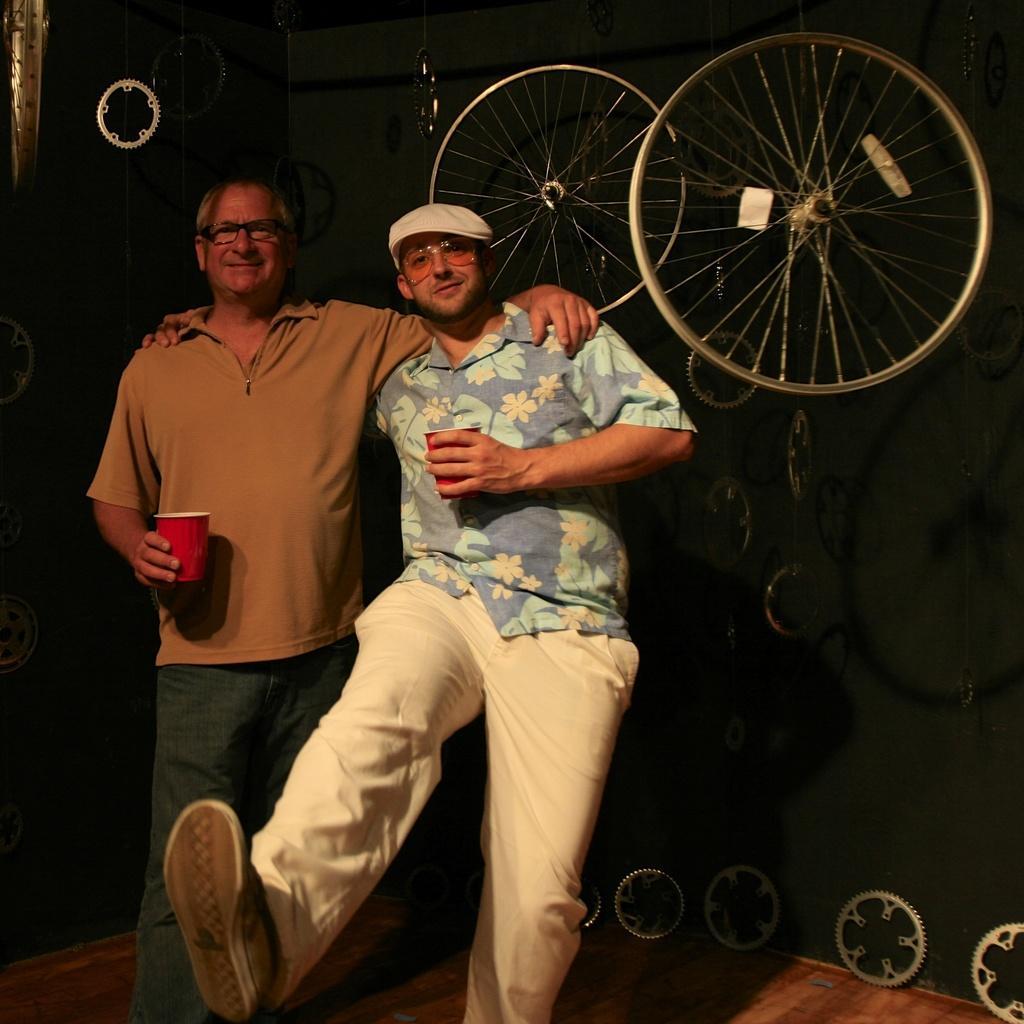Please provide a concise description of this image. In this image we can see two member standing holding a glass. In the background of the image there are tires and gears. At the bottom of the image there is wooden flooring. 